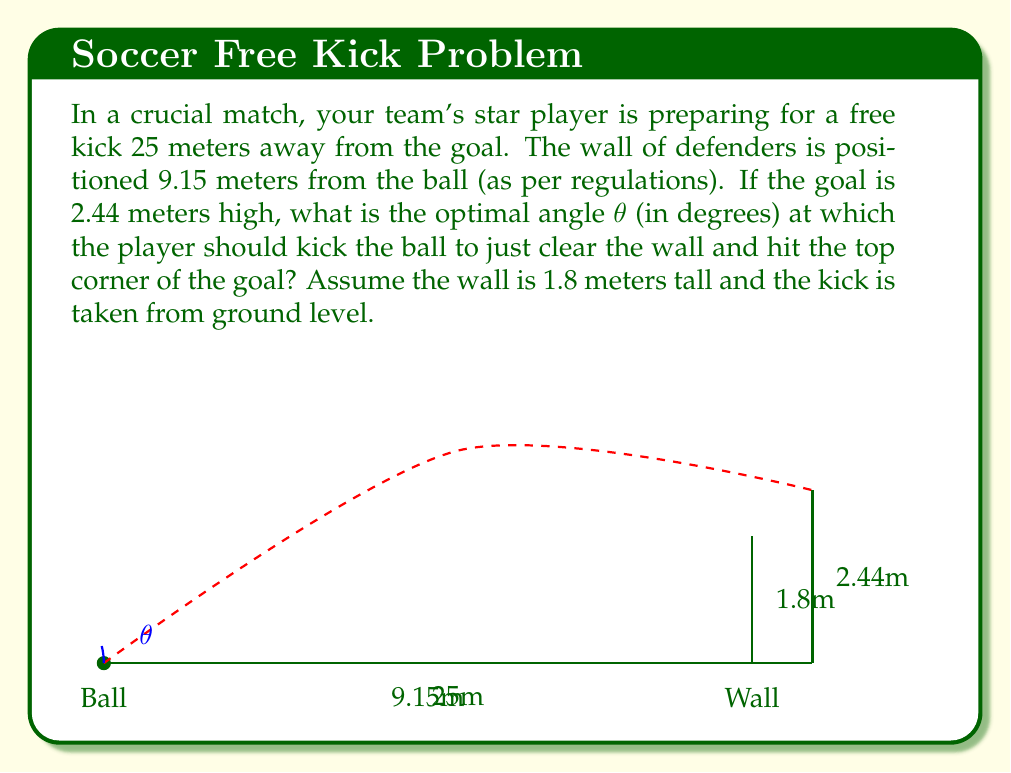Give your solution to this math problem. To solve this problem, we'll use trigonometry. Let's break it down step by step:

1) First, we need to find the height difference between the top of the wall and the top of the goal:
   $2.44m - 1.8m = 0.64m$

2) Now we have a right triangle. The base of this triangle is the distance from the wall to the goal:
   $25m - 9.15m = 15.85m$

3) We can now use the arctangent function to find the angle. The tangent of the angle is the opposite side divided by the adjacent side:

   $$\tan(\theta) = \frac{0.64}{15.85}$$

4) To get the angle, we take the inverse tangent (arctangent):

   $$\theta = \arctan(\frac{0.64}{15.85})$$

5) Calculate this value:

   $$\theta = \arctan(0.0403785) \approx 2.31°$$

6) However, this is just the angle above the wall. We need to add this to the angle required to reach the top of the wall.

7) For the wall, we have:
   $$\tan(\phi) = \frac{1.8}{9.15}$$
   $$\phi = \arctan(\frac{1.8}{9.15}) \approx 11.12°$$

8) The optimal angle is the sum of these two angles:

   $$\text{Optimal Angle} = 2.31° + 11.12° = 13.43°$$

9) Rounding to two decimal places, we get 13.43°.
Answer: The optimal angle for the free kick is approximately $13.43°$. 